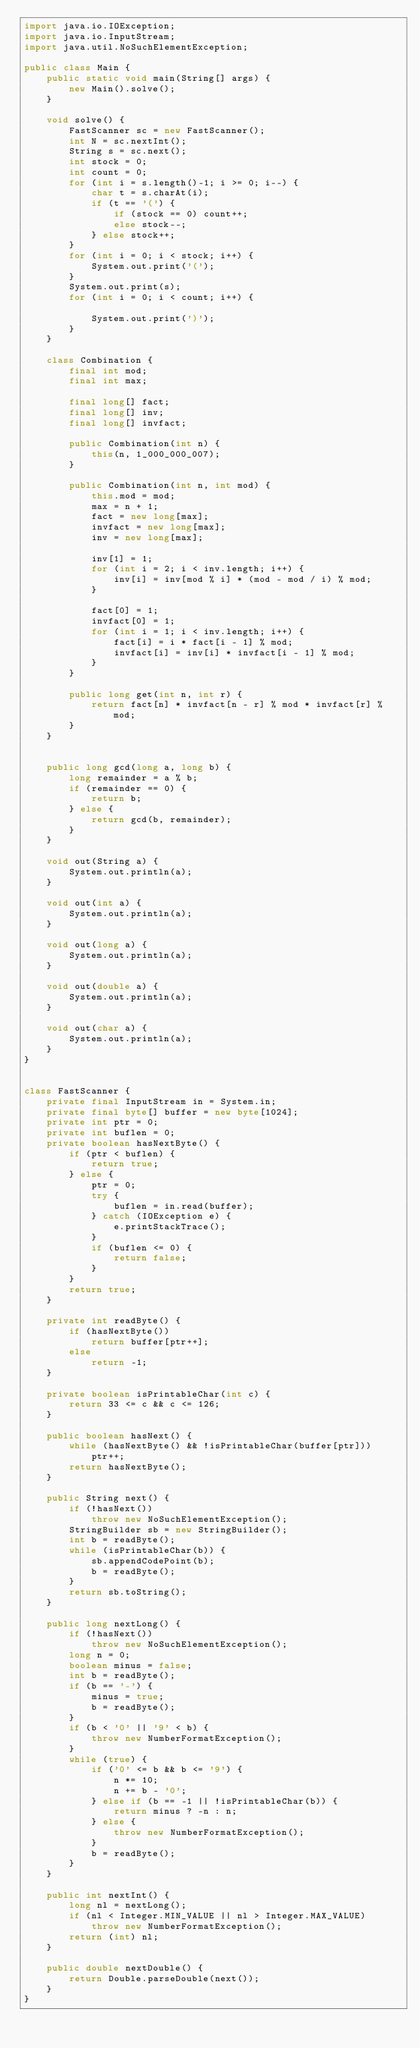Convert code to text. <code><loc_0><loc_0><loc_500><loc_500><_Java_>import java.io.IOException;
import java.io.InputStream;
import java.util.NoSuchElementException;

public class Main {
	public static void main(String[] args) {
		new Main().solve();
	}

	void solve() {
		FastScanner sc = new FastScanner();
		int N = sc.nextInt();
		String s = sc.next();
		int stock = 0;
		int count = 0;
		for (int i = s.length()-1; i >= 0; i--) {
			char t = s.charAt(i);
			if (t == '(') {
				if (stock == 0) count++;
				else stock--;
			} else stock++;
		}
		for (int i = 0; i < stock; i++) {
			System.out.print('(');
		}
		System.out.print(s);
		for (int i = 0; i < count; i++) {

			System.out.print(')');
		}
	}

	class Combination {
		final int mod;
		final int max;

		final long[] fact;
		final long[] inv;
		final long[] invfact;

		public Combination(int n) {
			this(n, 1_000_000_007);
		}

		public Combination(int n, int mod) {
			this.mod = mod;
			max = n + 1;
			fact = new long[max];
			invfact = new long[max];
			inv = new long[max];

			inv[1] = 1;
			for (int i = 2; i < inv.length; i++) {
				inv[i] = inv[mod % i] * (mod - mod / i) % mod;
			}

			fact[0] = 1;
			invfact[0] = 1;
			for (int i = 1; i < inv.length; i++) {
				fact[i] = i * fact[i - 1] % mod;
				invfact[i] = inv[i] * invfact[i - 1] % mod;
			}
		}

		public long get(int n, int r) {
			return fact[n] * invfact[n - r] % mod * invfact[r] % mod;
		}
	}


	public long gcd(long a, long b) {
		long remainder = a % b;
		if (remainder == 0) {
			return b;
		} else {
			return gcd(b, remainder);
		}
	}

	void out(String a) {
		System.out.println(a);
	}

	void out(int a) {
		System.out.println(a);
	}

	void out(long a) {
		System.out.println(a);
	}

	void out(double a) {
		System.out.println(a);
	}

	void out(char a) {
		System.out.println(a);
	}
}


class FastScanner {
    private final InputStream in = System.in;
    private final byte[] buffer = new byte[1024];
    private int ptr = 0;
    private int buflen = 0;
    private boolean hasNextByte() {
        if (ptr < buflen) {
            return true;
        } else {
            ptr = 0;
            try {
                buflen = in.read(buffer);
            } catch (IOException e) {
                e.printStackTrace();
            }
            if (buflen <= 0) {
                return false;
            }
        }
        return true;
    }

    private int readByte() {
        if (hasNextByte())
            return buffer[ptr++];
        else
            return -1;
    }

    private boolean isPrintableChar(int c) {
        return 33 <= c && c <= 126;
    }

    public boolean hasNext() {
        while (hasNextByte() && !isPrintableChar(buffer[ptr]))
            ptr++;
        return hasNextByte();
    }

    public String next() {
        if (!hasNext())
            throw new NoSuchElementException();
        StringBuilder sb = new StringBuilder();
        int b = readByte();
        while (isPrintableChar(b)) {
            sb.appendCodePoint(b);
            b = readByte();
        }
        return sb.toString();
    }

    public long nextLong() {
        if (!hasNext())
            throw new NoSuchElementException();
        long n = 0;
        boolean minus = false;
        int b = readByte();
        if (b == '-') {
            minus = true;
            b = readByte();
        }
        if (b < '0' || '9' < b) {
            throw new NumberFormatException();
        }
        while (true) {
            if ('0' <= b && b <= '9') {
                n *= 10;
                n += b - '0';
            } else if (b == -1 || !isPrintableChar(b)) {
                return minus ? -n : n;
            } else {
                throw new NumberFormatException();
            }
            b = readByte();
        }
    }

    public int nextInt() {
        long nl = nextLong();
        if (nl < Integer.MIN_VALUE || nl > Integer.MAX_VALUE)
            throw new NumberFormatException();
        return (int) nl;
    }

    public double nextDouble() {
        return Double.parseDouble(next());
    }
}
</code> 